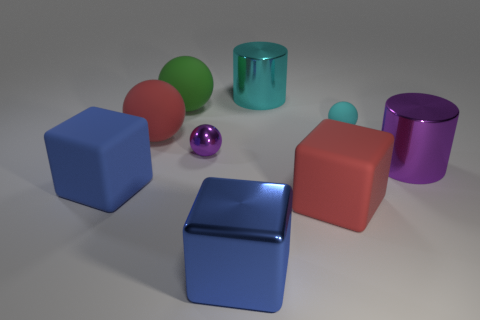Could you describe which objects in the image might interact together in a real-world setting, and how? In a real-world scenario, the objects might be part of a children's play area or educational setup. For example, the spheres and cubes could be used together in a sorting or building activity where children categorize them by color or shape. The metallic cylinders might be part of a more sophisticated building set, possibly used for constructing simple machinery or for learning about physics properties like light reflection or magnetism. 